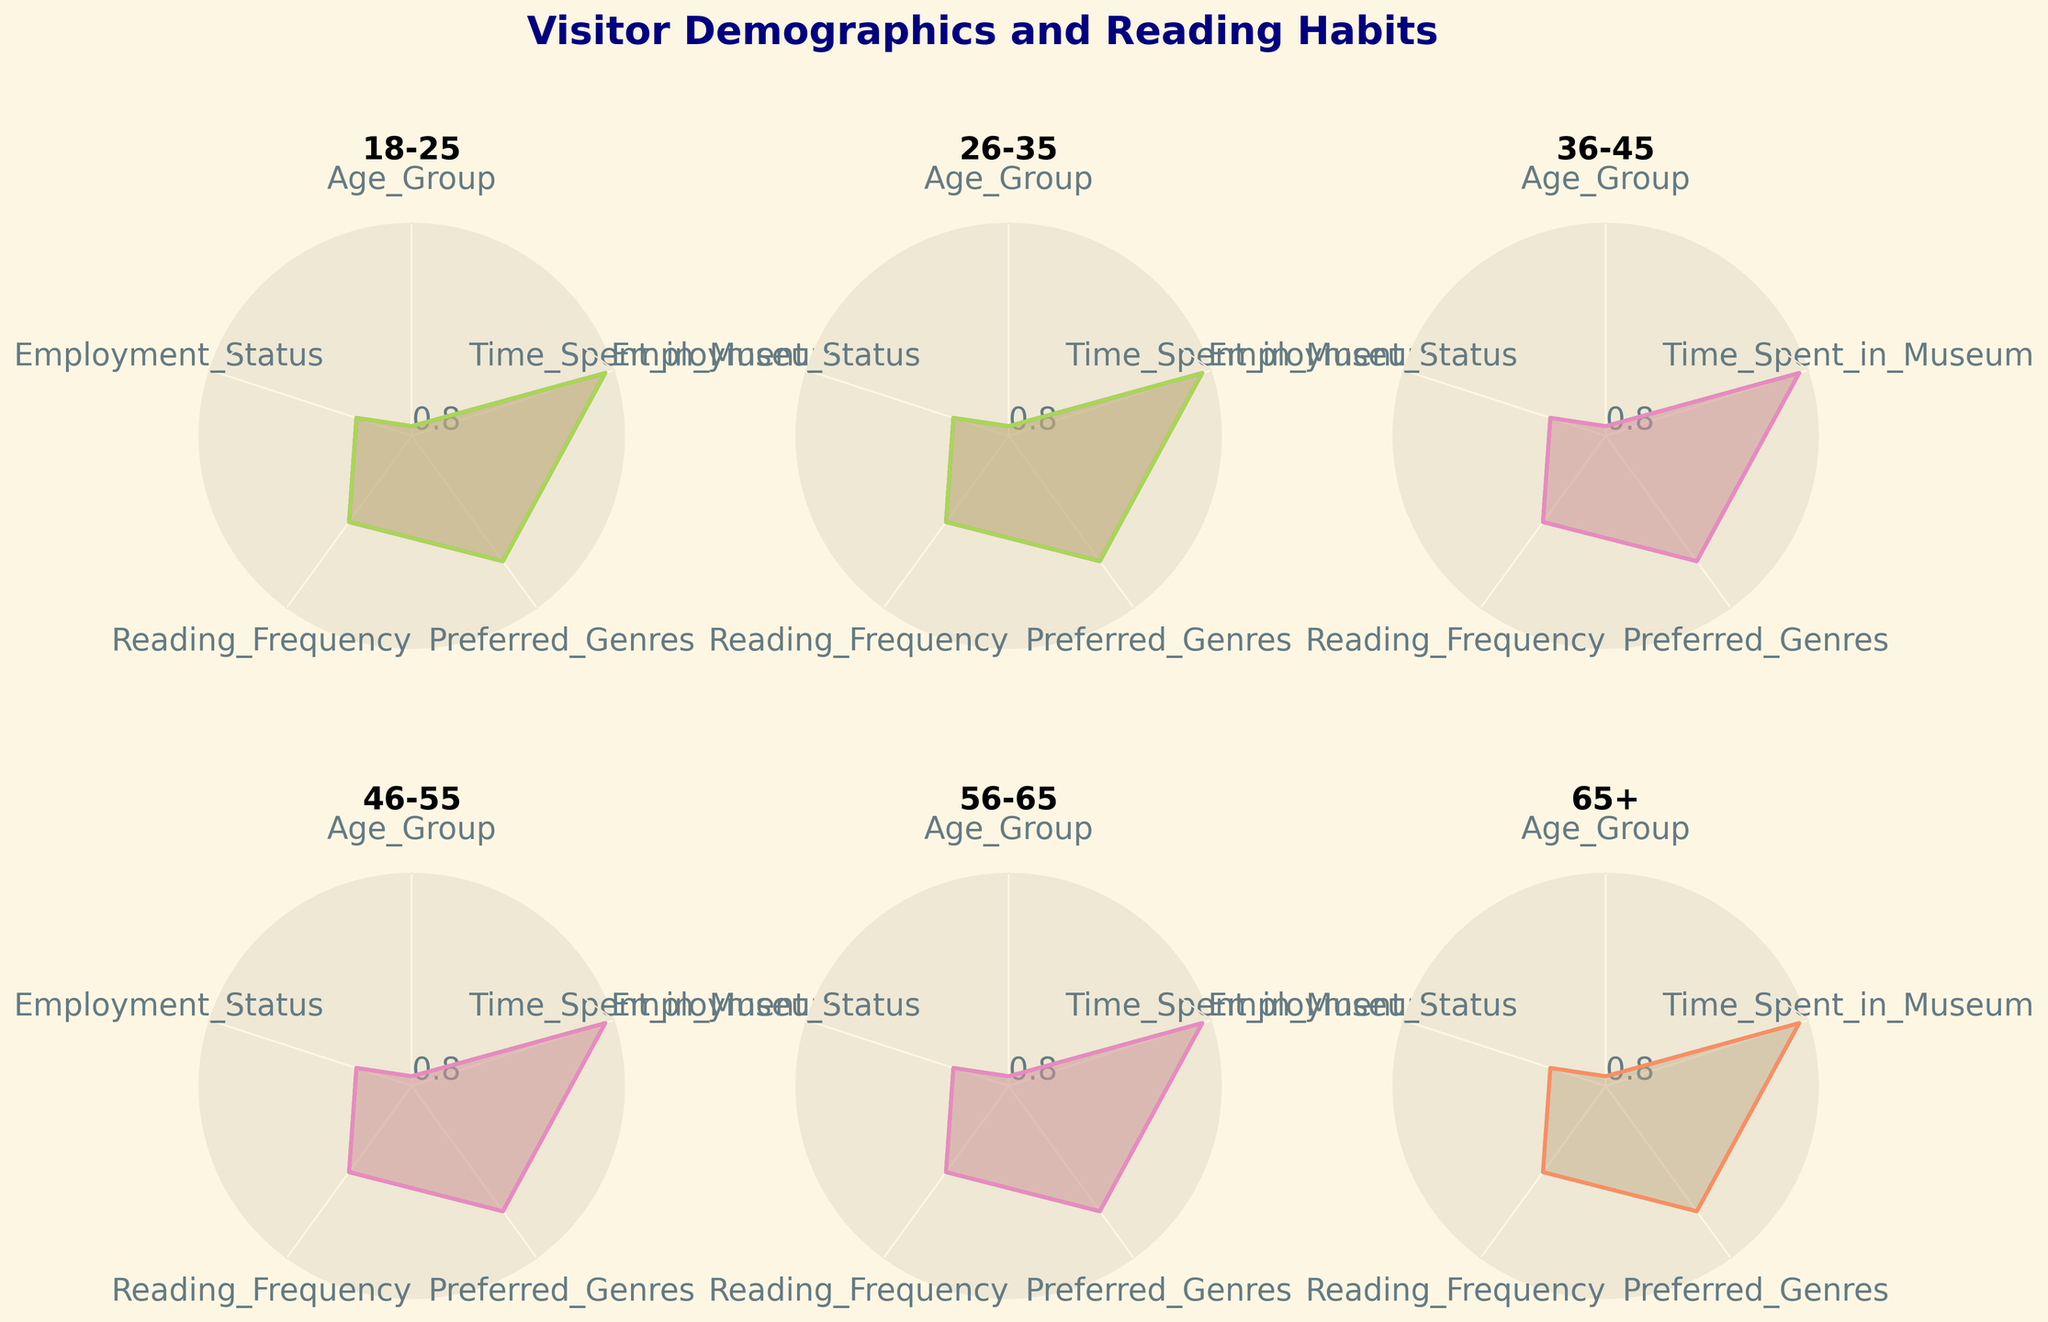What are the five categories displayed on the radar charts? The radar charts display five distinct categories. These categories are arranged around the chart and connected by lines to form a closed shape. The categories listed are 'Age Group', 'Employment Status', 'Reading Frequency', 'Preferred Genres', and 'Time Spent in Museum'.
Answer: Age Group, Employment Status, Reading Frequency, Preferred Genres, Time Spent in Museum Which age group spends the most time in the museum? To determine which age group spends the most time in the museum, we look at the values for the 'Time Spent in Museum' category. By examining the charts, we can see that the '65+' age group has the highest values in this category.
Answer: 65+ How does reading frequency vary among the different age groups? To evaluate the variation in reading frequency among different age groups, an examination of the 'Reading Frequency' category in each radar chart for different age groups is required. Many age groups show a frequent reading habit, but trends and specific variations can be identified from the individual charts.
Answer: Daily reading is common, but variations exist Compare the employment status of the age groups 18-25 and 26-35. Which group has more full-time employees? The 'Employment Status' category in the radar charts for age groups 18-25 and 26-35 must be compared. The values under 'Employment Status' indicate that the 26-35 age group has a higher number of full-time employees compared to the 18-25 age group. Specifically, the line segment from this category reaches farther out in the radar chart for the 26-35 age group.
Answer: 26-35 Which age group shows the most diversity in preferred genres? The diversity in preferred genres can be discerned by analyzing the range and variation of values in the 'Preferred Genres' category across the radar charts. The group with the most varied and less peaked segments in this category indicates a wide range of preferred genres. The 36-45 age group shows preferences for Fiction, History, Biography, and Non-fiction, indicating more diversity.
Answer: 36-45 Does the employment status of the 56-65 age group differ significantly from that of the 65+ age group? Comparing the radar charts for the 56-65 age group and the 65+ age group reveals differences in employment status. The radar chart for the 65+ age group shows a larger portion of retirees compared to the 56-65 age group, which indicates that employment status does differ significantly between these two groups.
Answer: Yes Is there a trend in the frequency of museum visits among different age groups? To identify a trend in the frequency of museum visits among different age groups, the 'Time Spent in Museum' category must be examined across all age group radar charts. The radar charts indicate that older age groups tend to spend more time at the museum, with the highest time spent being in the 65+ category.
Answer: Older age groups spend more time Which genre is preferred by most 18-25 year-olds? To find the preferred genre for the 18-25 age group, we look at the radar chart for this group and the value corresponding to 'Preferred Genres'. The chart for the 18-25 age group shows that Fiction is the preferred genre, as indicated by the peak in this category.
Answer: Fiction What is the primary employment status for age group 46-55? Evaluating the 'Employment Status' category in the radar chart for the 46-55 age group reveals the primary employment status. The radar chart shows that Self-employed is the primary employment status for this age group, as indicated by the highest peak in this category.
Answer: Self-employed 